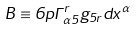<formula> <loc_0><loc_0><loc_500><loc_500>B \equiv 6 p \Gamma _ { \alpha 5 } ^ { r } g _ { 5 r } d x ^ { \alpha }</formula> 